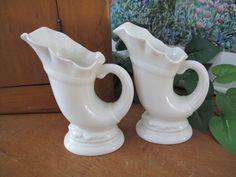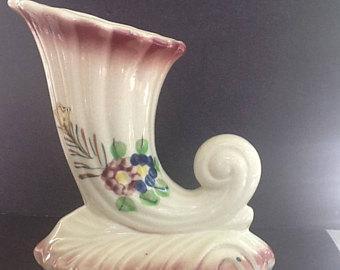The first image is the image on the left, the second image is the image on the right. For the images shown, is this caption "One of the images shows two identical vases next to each other." true? Answer yes or no. Yes. 